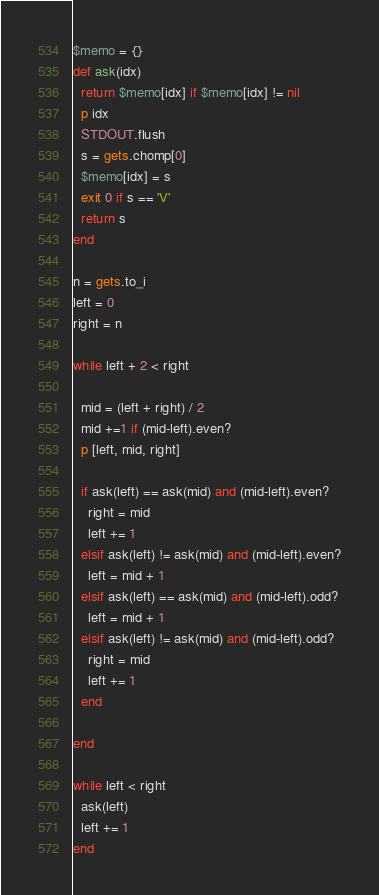Convert code to text. <code><loc_0><loc_0><loc_500><loc_500><_Ruby_>$memo = {}
def ask(idx)
  return $memo[idx] if $memo[idx] != nil
  p idx
  STDOUT.flush
  s = gets.chomp[0]
  $memo[idx] = s
  exit 0 if s == 'V'
  return s
end

n = gets.to_i
left = 0
right = n

while left + 2 < right

  mid = (left + right) / 2
  mid +=1 if (mid-left).even?
  p [left, mid, right]

  if ask(left) == ask(mid) and (mid-left).even?
    right = mid
    left += 1
  elsif ask(left) != ask(mid) and (mid-left).even?
    left = mid + 1
  elsif ask(left) == ask(mid) and (mid-left).odd?
    left = mid + 1
  elsif ask(left) != ask(mid) and (mid-left).odd?
    right = mid
    left += 1
  end

end

while left < right
  ask(left)
  left += 1
end
</code> 